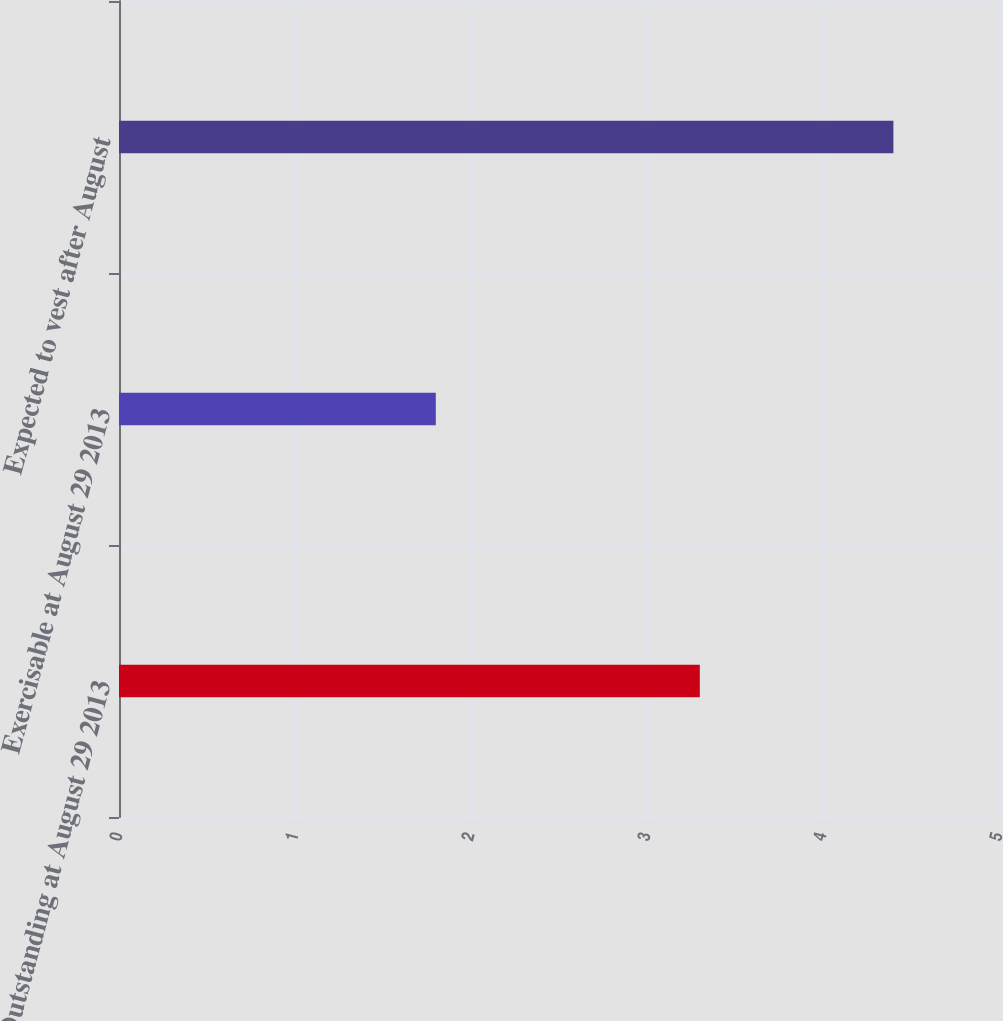<chart> <loc_0><loc_0><loc_500><loc_500><bar_chart><fcel>Outstanding at August 29 2013<fcel>Exercisable at August 29 2013<fcel>Expected to vest after August<nl><fcel>3.3<fcel>1.8<fcel>4.4<nl></chart> 